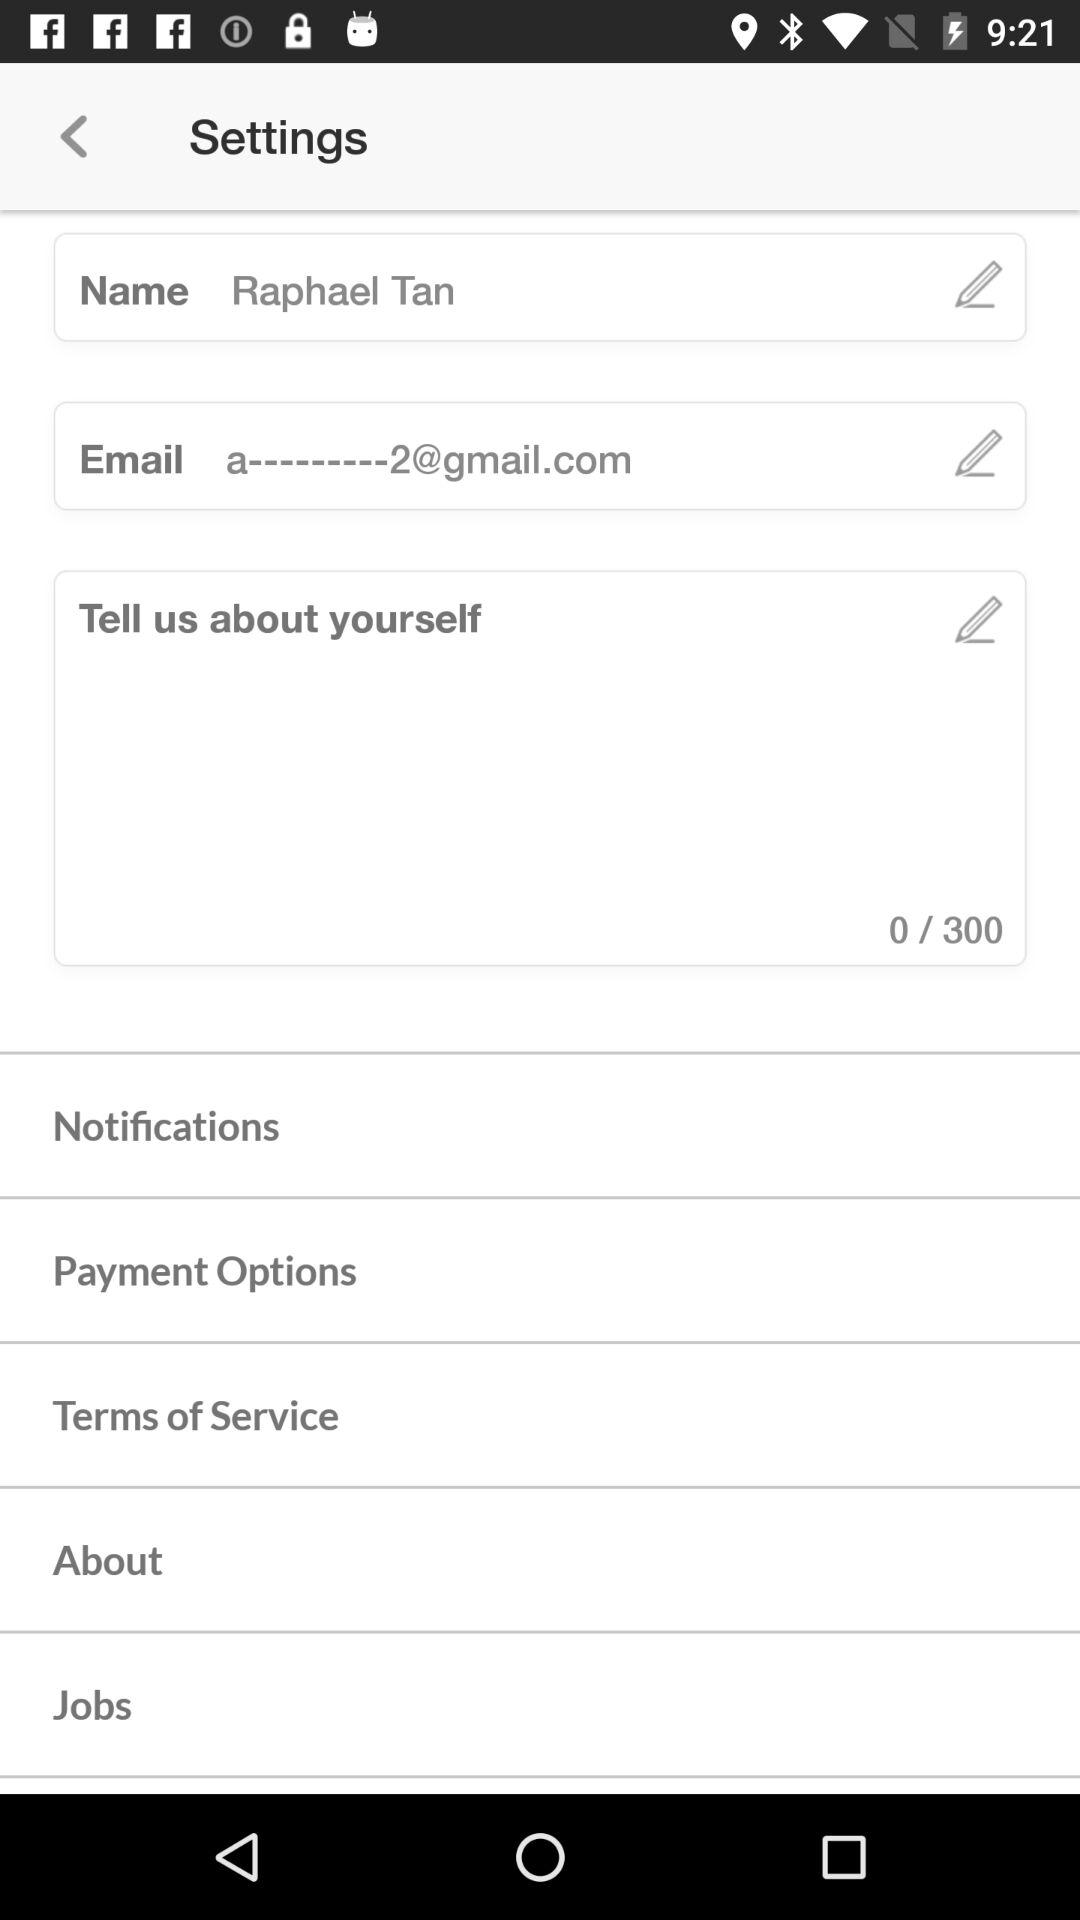What is the name of the user? The name of the user is Raphael Tan. 